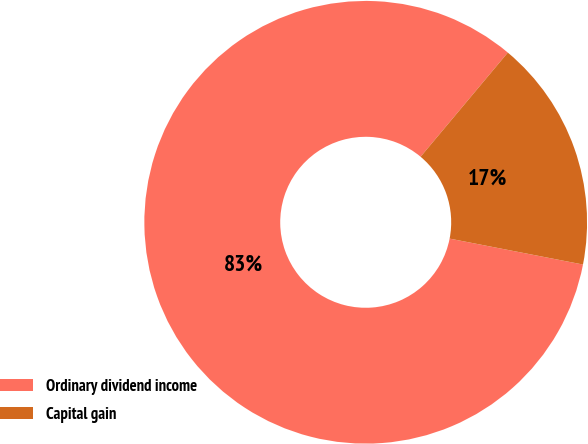Convert chart. <chart><loc_0><loc_0><loc_500><loc_500><pie_chart><fcel>Ordinary dividend income<fcel>Capital gain<nl><fcel>83.04%<fcel>16.96%<nl></chart> 